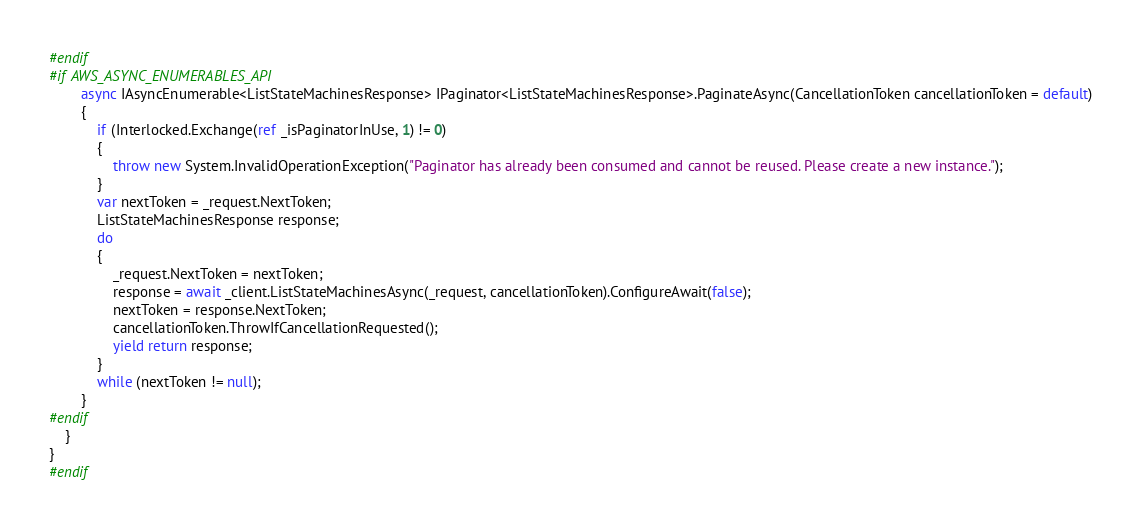<code> <loc_0><loc_0><loc_500><loc_500><_C#_>#endif
#if AWS_ASYNC_ENUMERABLES_API
        async IAsyncEnumerable<ListStateMachinesResponse> IPaginator<ListStateMachinesResponse>.PaginateAsync(CancellationToken cancellationToken = default)
        {
            if (Interlocked.Exchange(ref _isPaginatorInUse, 1) != 0)
            {
                throw new System.InvalidOperationException("Paginator has already been consumed and cannot be reused. Please create a new instance.");
            }
            var nextToken = _request.NextToken;
            ListStateMachinesResponse response;
            do
            {
                _request.NextToken = nextToken;
                response = await _client.ListStateMachinesAsync(_request, cancellationToken).ConfigureAwait(false);
                nextToken = response.NextToken;
                cancellationToken.ThrowIfCancellationRequested();
                yield return response;
            }
            while (nextToken != null);
        }
#endif
    }
}
#endif</code> 